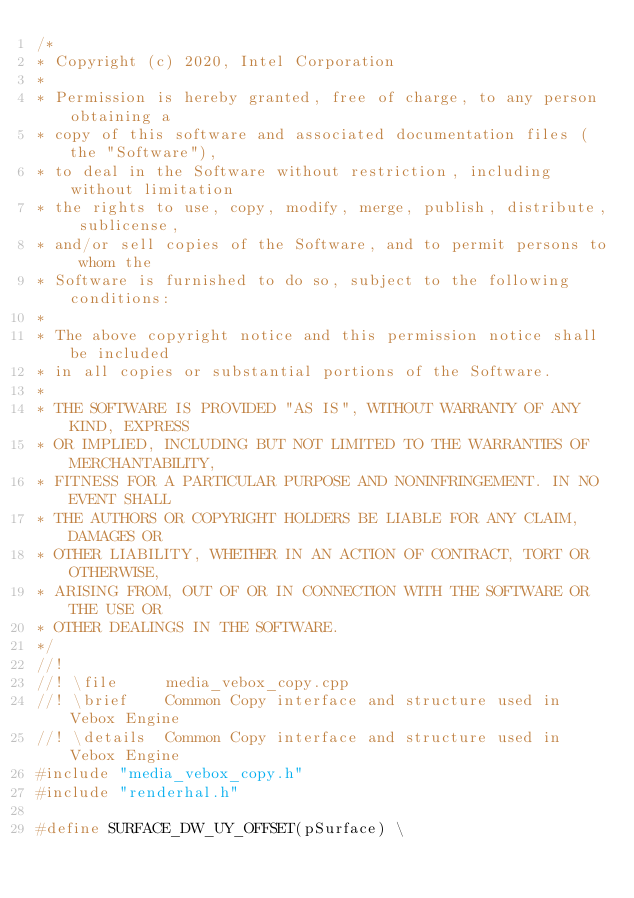<code> <loc_0><loc_0><loc_500><loc_500><_C++_>/*
* Copyright (c) 2020, Intel Corporation
*
* Permission is hereby granted, free of charge, to any person obtaining a
* copy of this software and associated documentation files (the "Software"),
* to deal in the Software without restriction, including without limitation
* the rights to use, copy, modify, merge, publish, distribute, sublicense,
* and/or sell copies of the Software, and to permit persons to whom the
* Software is furnished to do so, subject to the following conditions:
*
* The above copyright notice and this permission notice shall be included
* in all copies or substantial portions of the Software.
*
* THE SOFTWARE IS PROVIDED "AS IS", WITHOUT WARRANTY OF ANY KIND, EXPRESS
* OR IMPLIED, INCLUDING BUT NOT LIMITED TO THE WARRANTIES OF MERCHANTABILITY,
* FITNESS FOR A PARTICULAR PURPOSE AND NONINFRINGEMENT. IN NO EVENT SHALL
* THE AUTHORS OR COPYRIGHT HOLDERS BE LIABLE FOR ANY CLAIM, DAMAGES OR
* OTHER LIABILITY, WHETHER IN AN ACTION OF CONTRACT, TORT OR OTHERWISE,
* ARISING FROM, OUT OF OR IN CONNECTION WITH THE SOFTWARE OR THE USE OR
* OTHER DEALINGS IN THE SOFTWARE.
*/
//!
//! \file     media_vebox_copy.cpp
//! \brief    Common Copy interface and structure used in Vebox Engine
//! \details  Common Copy interface and structure used in Vebox Engine
#include "media_vebox_copy.h"
#include "renderhal.h"

#define SURFACE_DW_UY_OFFSET(pSurface) \</code> 